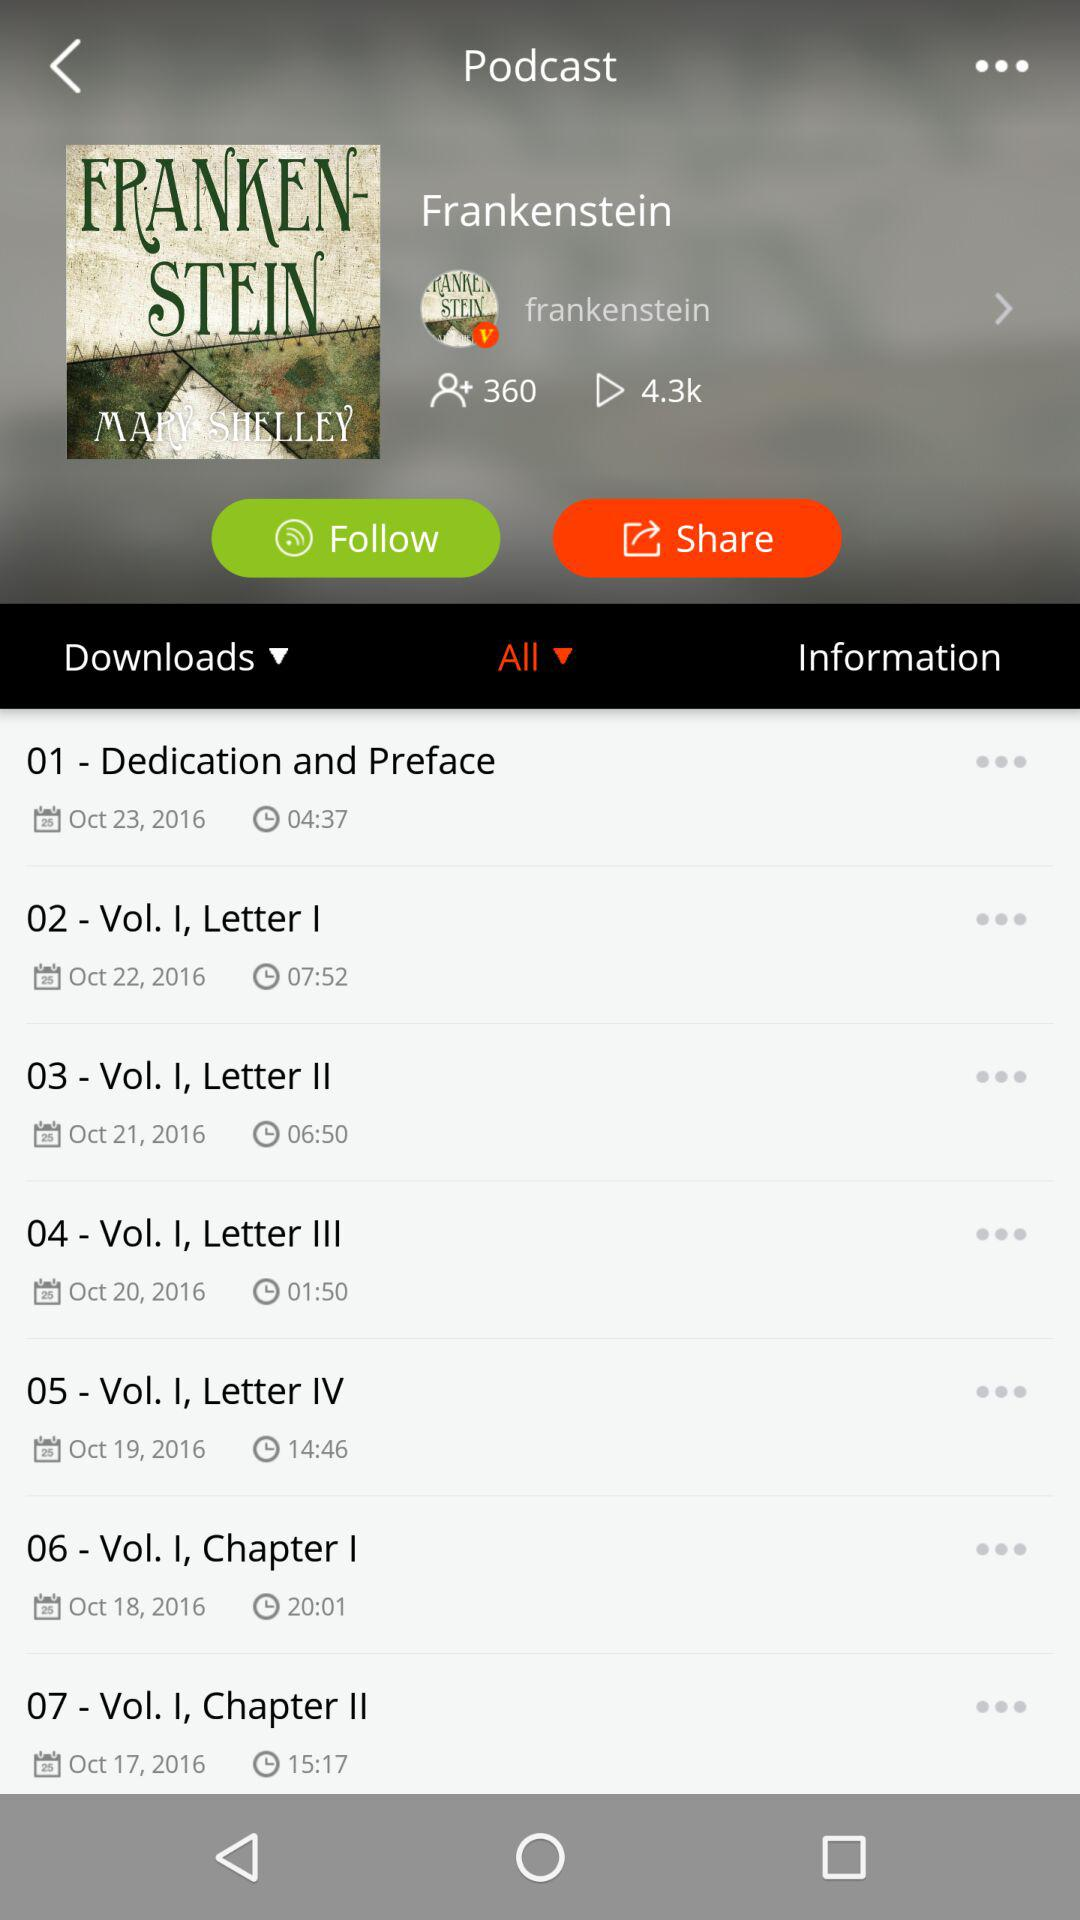What is the date of "Vol. I, Letter I"? The date is October 22, 2016. 